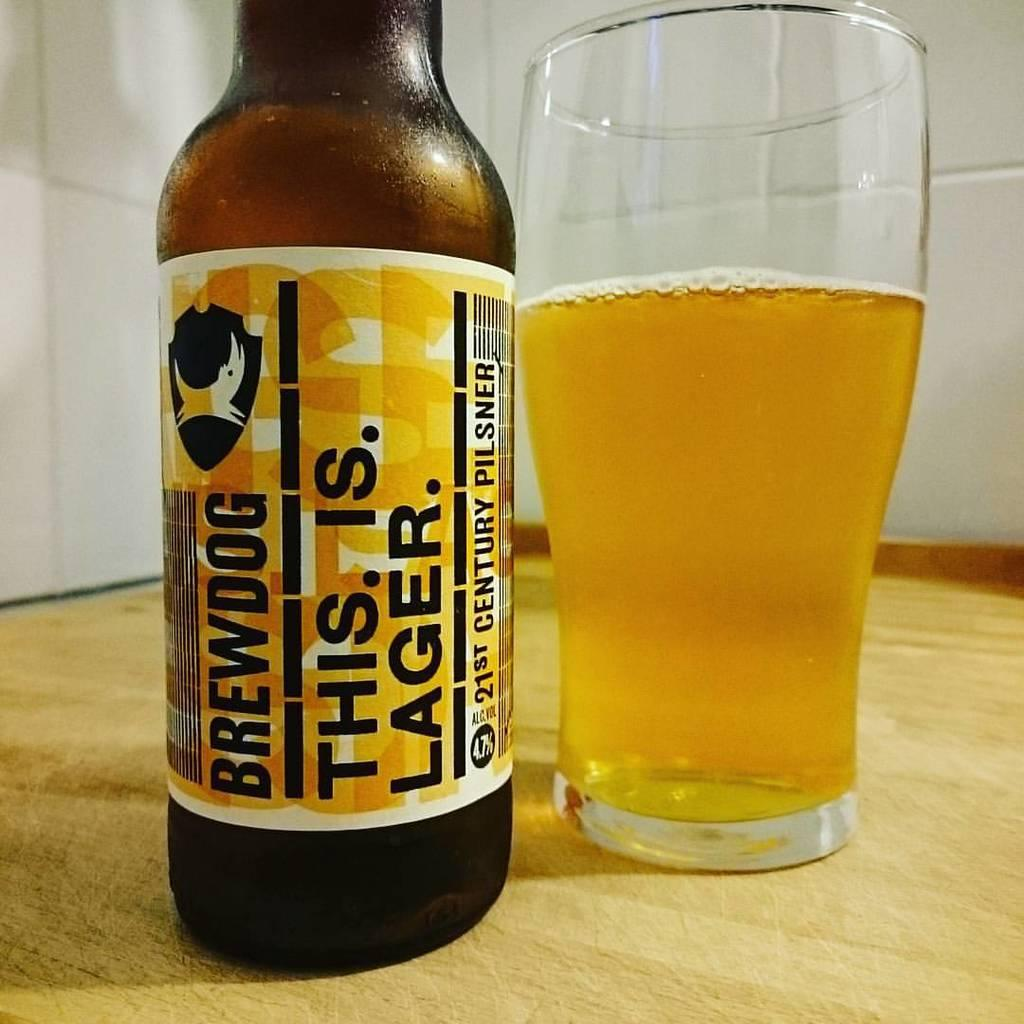<image>
Render a clear and concise summary of the photo. A This. Is. Lager. Brewdog beer next to a glass with some beer in it. 